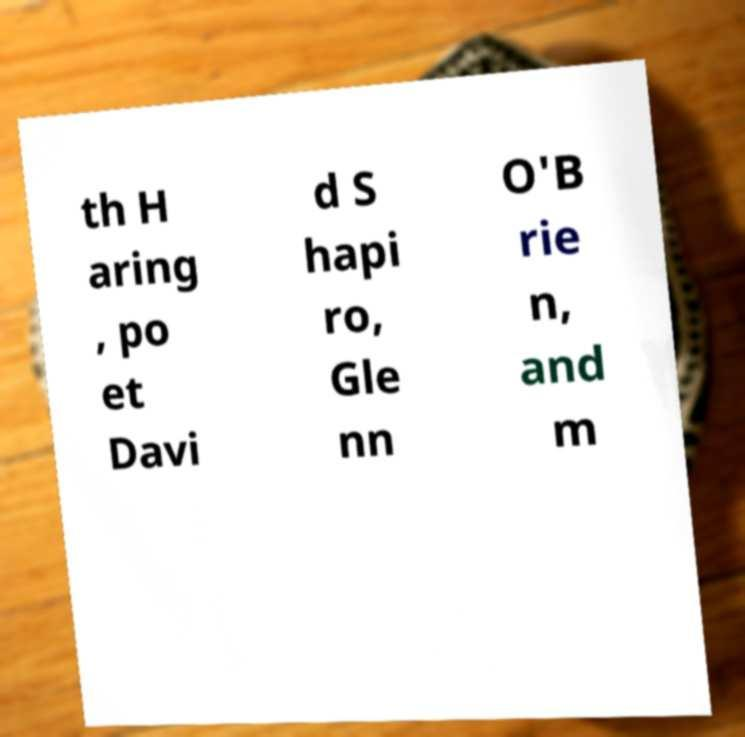Could you assist in decoding the text presented in this image and type it out clearly? th H aring , po et Davi d S hapi ro, Gle nn O'B rie n, and m 